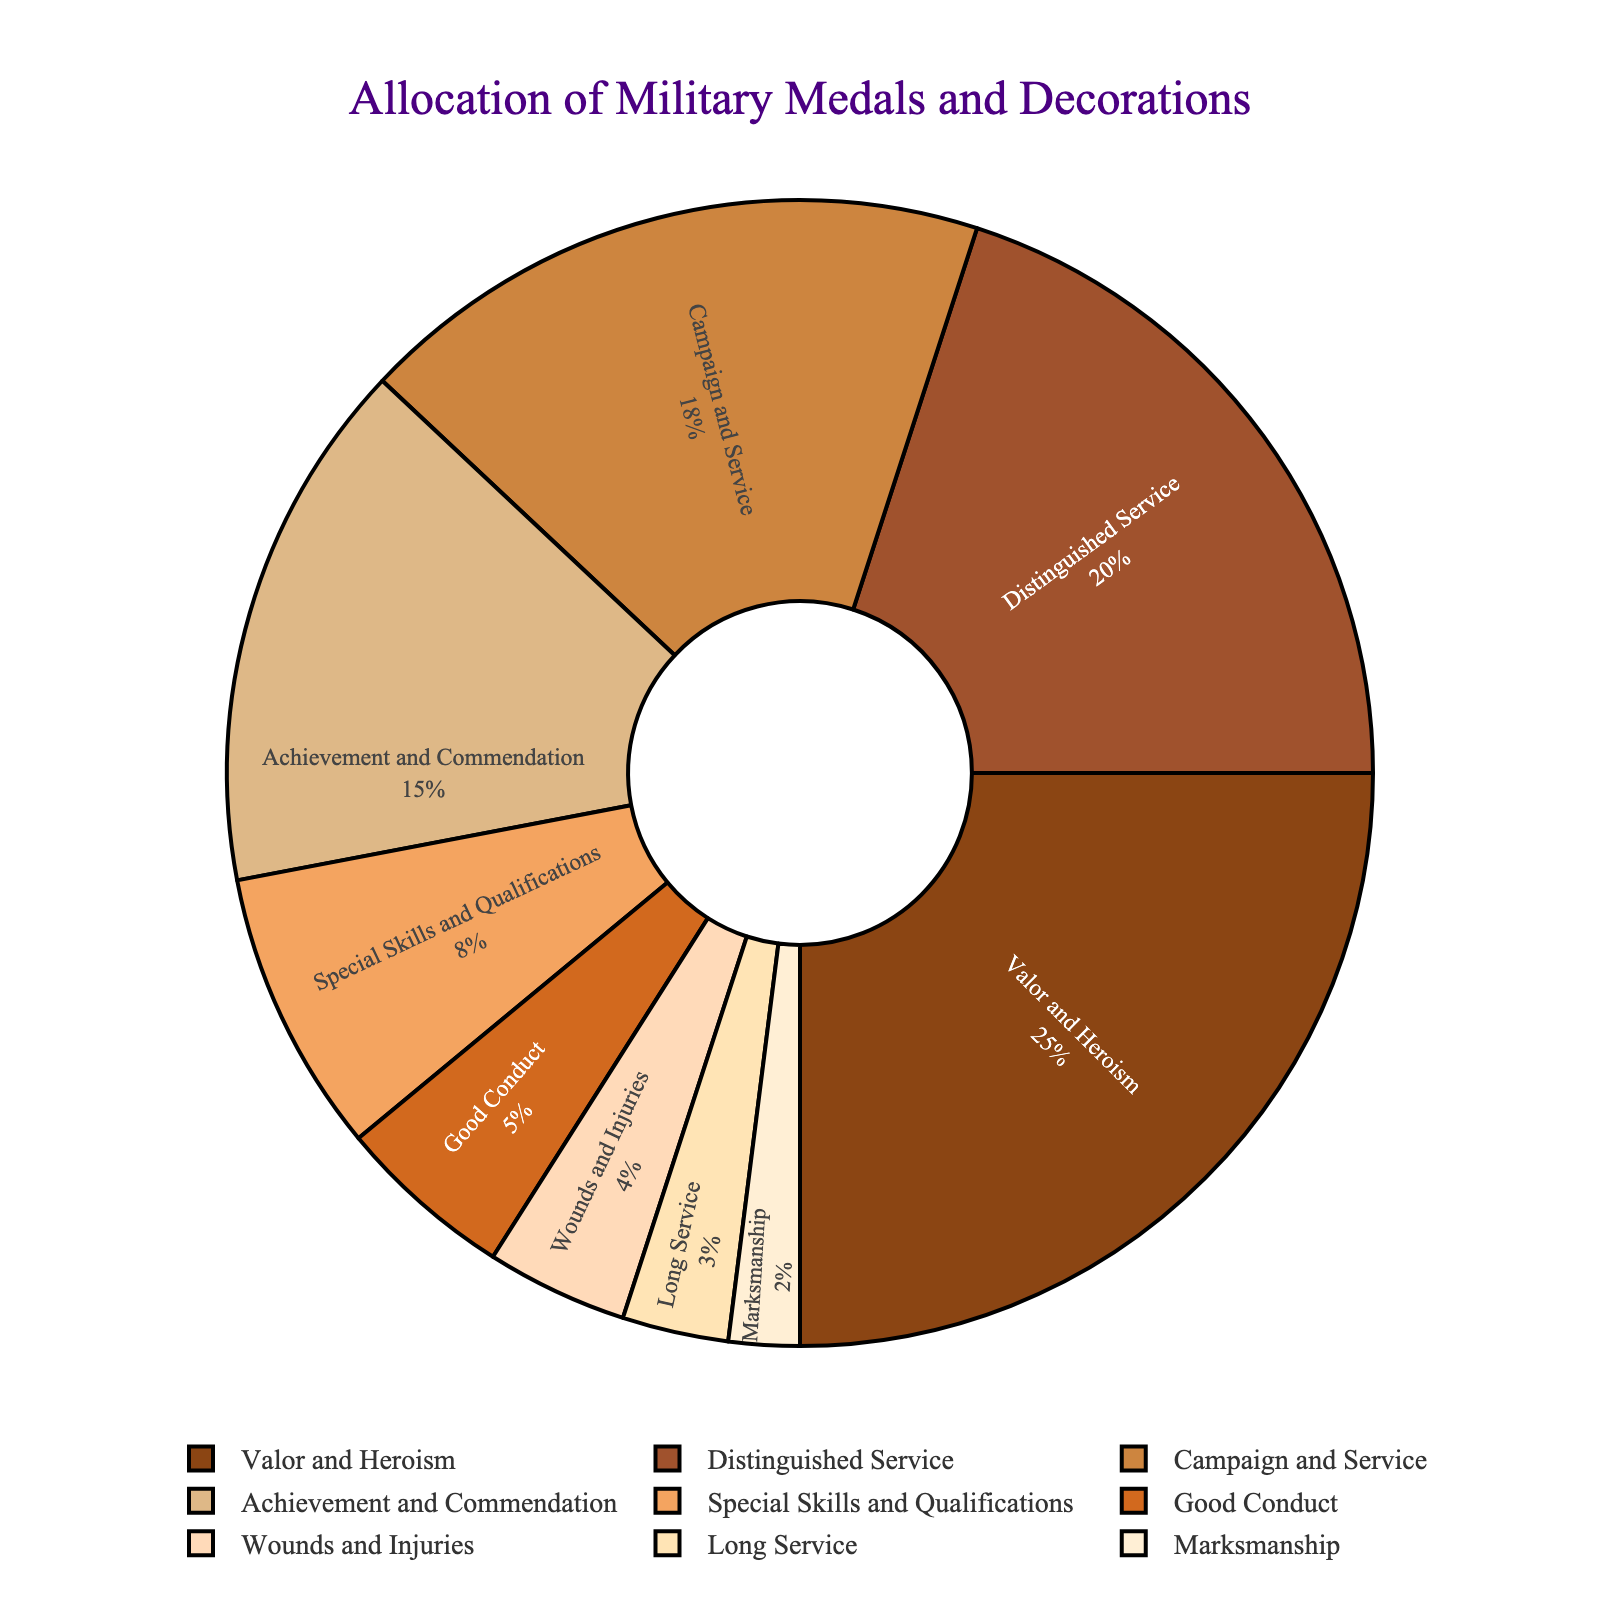Which category has the highest allocation percentage? The slice representing "Valor and Heroism" has the largest area on the pie chart, and text inside the slice shows 25%, which is the highest percentage among all categories.
Answer: Valor and Heroism Which two categories combined have a total allocation of 38%? By examining the percentages on the pie chart, "Campaign and Service" has 18% and "Achievement and Commendation" has 15%. Adding these percentages, 18% + 15% = 33%. Therefore, "Distinguished Service" (20%) and "Special Skills and Qualifications" (8%) combined give 20% + 8% = 28%. Adding these together, "Campaign and Service" (18%) and "Special Skills and Qualifications" (8%) makes up 26%, and so forth. Clearly, "Distinguished Service" (20%) and "Achievement and Commendation" (15%) gives 35%.Therefore, the only possible combination is "Campaign and Service" (18%) and "Achievement and Commendation" (15%) combined to make 38%.
Answer: Achievement and Commendation + Campaign and Service What is the difference in allocation percentage between "Good Conduct" and "Long Service"? Locate the slices labeled "Good Conduct" and "Long Service". The "Good Conduct" category is marked with 5%, and "Long Service" is marked with 3%. Calculate the difference: 5% - 3% = 2%.
Answer: 2% How many categories have an allocation percentage less than or equal to 10%? Examine the pie chart for each slice with percentages less than or equal to 10%. These categories are: "Special Skills and Qualifications" (8%), "Good Conduct" (5%), "Wounds and Injuries" (4%), "Long Service" (3%), and "Marksmanship" (2%). So, there are 5 categories in total.
Answer: 5 What is the combined allocation percentage of categories "Good Conduct", "Wounds and Injuries", and "Marksmanship"? Inspect the pie chart slices with labels "Good Conduct", "Wounds and Injuries", and "Marksmanship". "Good Conduct" is 5%, "Wounds and Injuries" is 4%, and "Marksmanship" is 2%. Adding these together: 5% + 4% + 2% = 11%.
Answer: 11% By how much does the percentage of "Valor and Heroism" exceed that of "Distinguished Service"? Refer to the pie chart; "Valor and Heroism" shows 25%, and "Distinguished Service" shows 20%. Subtract the "Distinguished Service" percentage from the "Valor and Heroism" percentage: 25% - 20% = 5%.
Answer: 5% Which category is represented by a lighter shade of brown and has an allocation percentage of 15%? Identify the slice with the light brown shade and the corresponding label. "Achievement and Commendation" is the category in question with a light brown color and a percentage of 15%.
Answer: Achievement and Commendation 